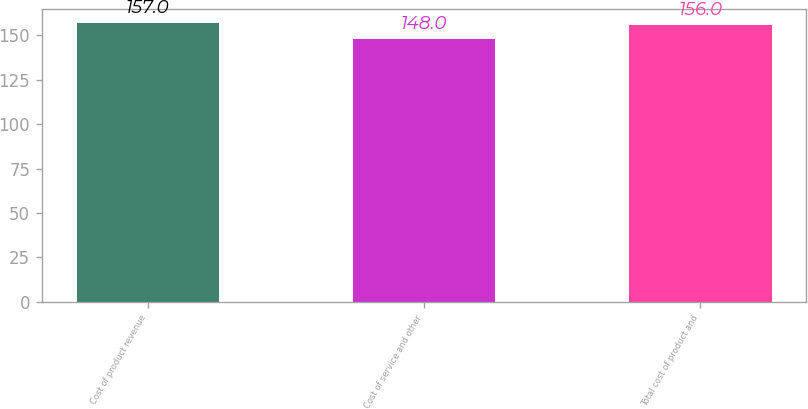Convert chart. <chart><loc_0><loc_0><loc_500><loc_500><bar_chart><fcel>Cost of product revenue<fcel>Cost of service and other<fcel>Total cost of product and<nl><fcel>157<fcel>148<fcel>156<nl></chart> 